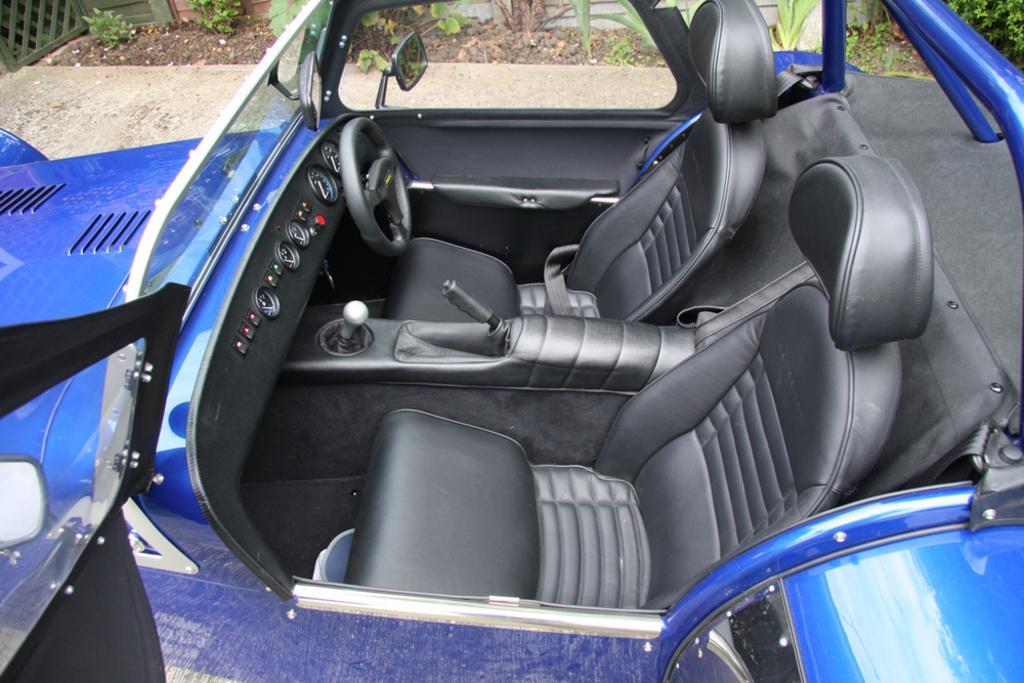In one or two sentences, can you explain what this image depicts? In this picture there is a top view of the car. In the front there is a black color seats, steering and cluster unit. In the front there is a blue color car bonnet. In the background we can see some plants on the ground. 